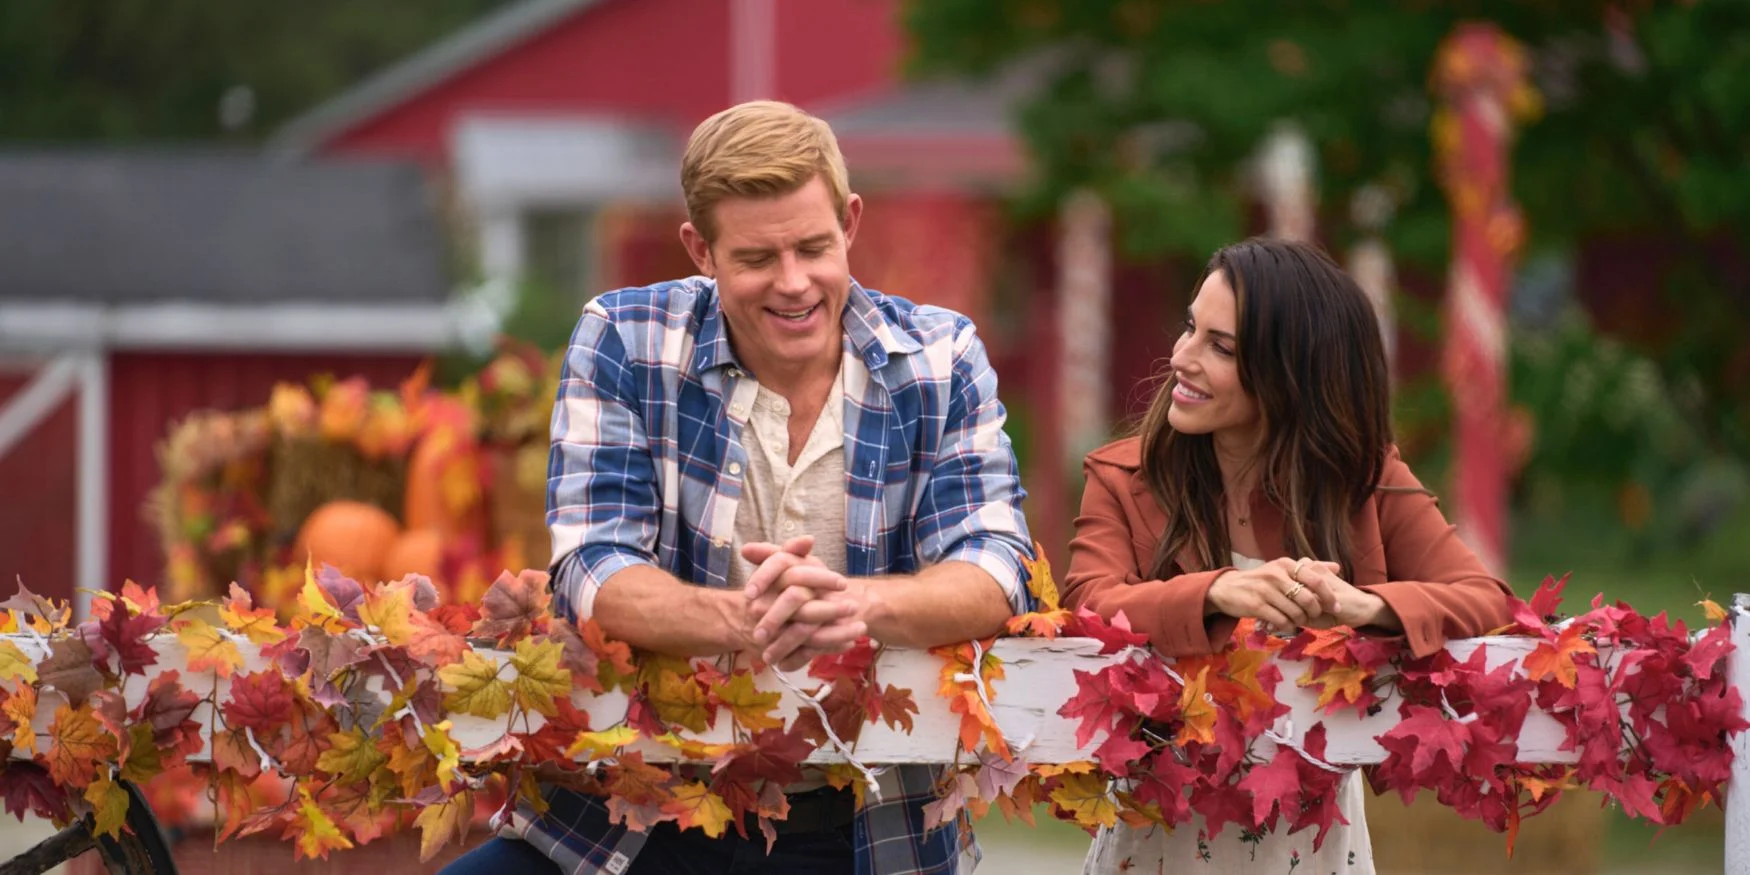Imagine a storyline for a movie scene based on this image. In this heartwarming movie scene, long-lost friends, Matt and Sarah, unexpectedly reunite at a quaint countryside farm during the peak of autumn. Having grown up together in the sharegpt4v/same small town, they lost touch over the years due to life's various twists and turns. Now, amidst the vibrant fall foliage and rustic charm of the red barn, they're reminiscing about old times and catching up on each other's lives. The pumpkins and vivid leaves symbolize the harvest of their shared memories and the new beginnings that await. As they reconnect, their conversation flows effortlessly, reigniting the deep bond they once had and sparking a journey of rediscovery and renewed friendship. Wow, that sounds fantastic! What could be the pivotal moment in this movie? The pivotal moment in this movie could occur when Matt and Sarah discover an old time capsule they buried as children under the large oak tree near the barn. As they unearth it, filled with letters, photographs, and mementos of their childhood dreams, they are overwhelmed with nostalgia and emotions. Among the items, they find a heartfelt letter they wrote to their future selves, promising to always be there for each other no matter where life takes them. This discovery reignites their bond and prompts them to reflect on how far they've come, ultimately leading to a deeper understanding and appreciation of their enduring friendship.  If these two individuals were characters in a fantasy world, what kind of adventure would they embark on? In a fantastical realm where autumn stretches eternally, these two characters, Elowen the Forest Guardian and Kael the Wanderer, would embark on an epic quest. Their journey begins in the enchanted forest surrounding the autumn village, where the vibrant leaves whisper ancient secrets. Elowen, with her deep connection to nature, senses a disturbance – the Eternal Tree of Seasons, which maintains the balance of the world's natural cycles, is dying. Kael, ever the adventurous spirit, agrees to join her. Together, they must venture into the heart of the realm, facing mythical creatures, deciphering cryptic prophecies, and navigating treacherous landscapes. Their quest is not only to save the Eternal Tree but to discover their own latent magical abilities and the truth about the intertwined fates of their ancestors. Along the way, they find their bond deepening, evolving from companions to soul-bound allies, destined to safeguard the harmony of their world. 